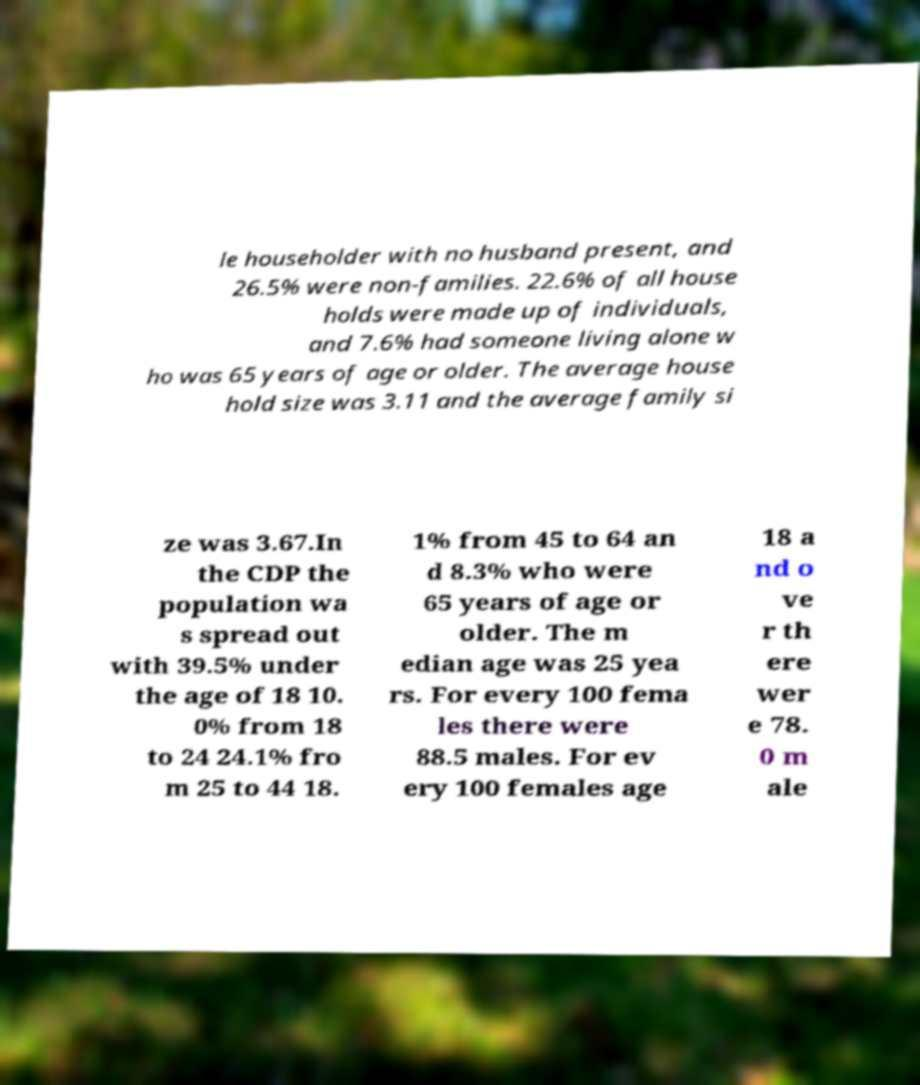Can you accurately transcribe the text from the provided image for me? le householder with no husband present, and 26.5% were non-families. 22.6% of all house holds were made up of individuals, and 7.6% had someone living alone w ho was 65 years of age or older. The average house hold size was 3.11 and the average family si ze was 3.67.In the CDP the population wa s spread out with 39.5% under the age of 18 10. 0% from 18 to 24 24.1% fro m 25 to 44 18. 1% from 45 to 64 an d 8.3% who were 65 years of age or older. The m edian age was 25 yea rs. For every 100 fema les there were 88.5 males. For ev ery 100 females age 18 a nd o ve r th ere wer e 78. 0 m ale 